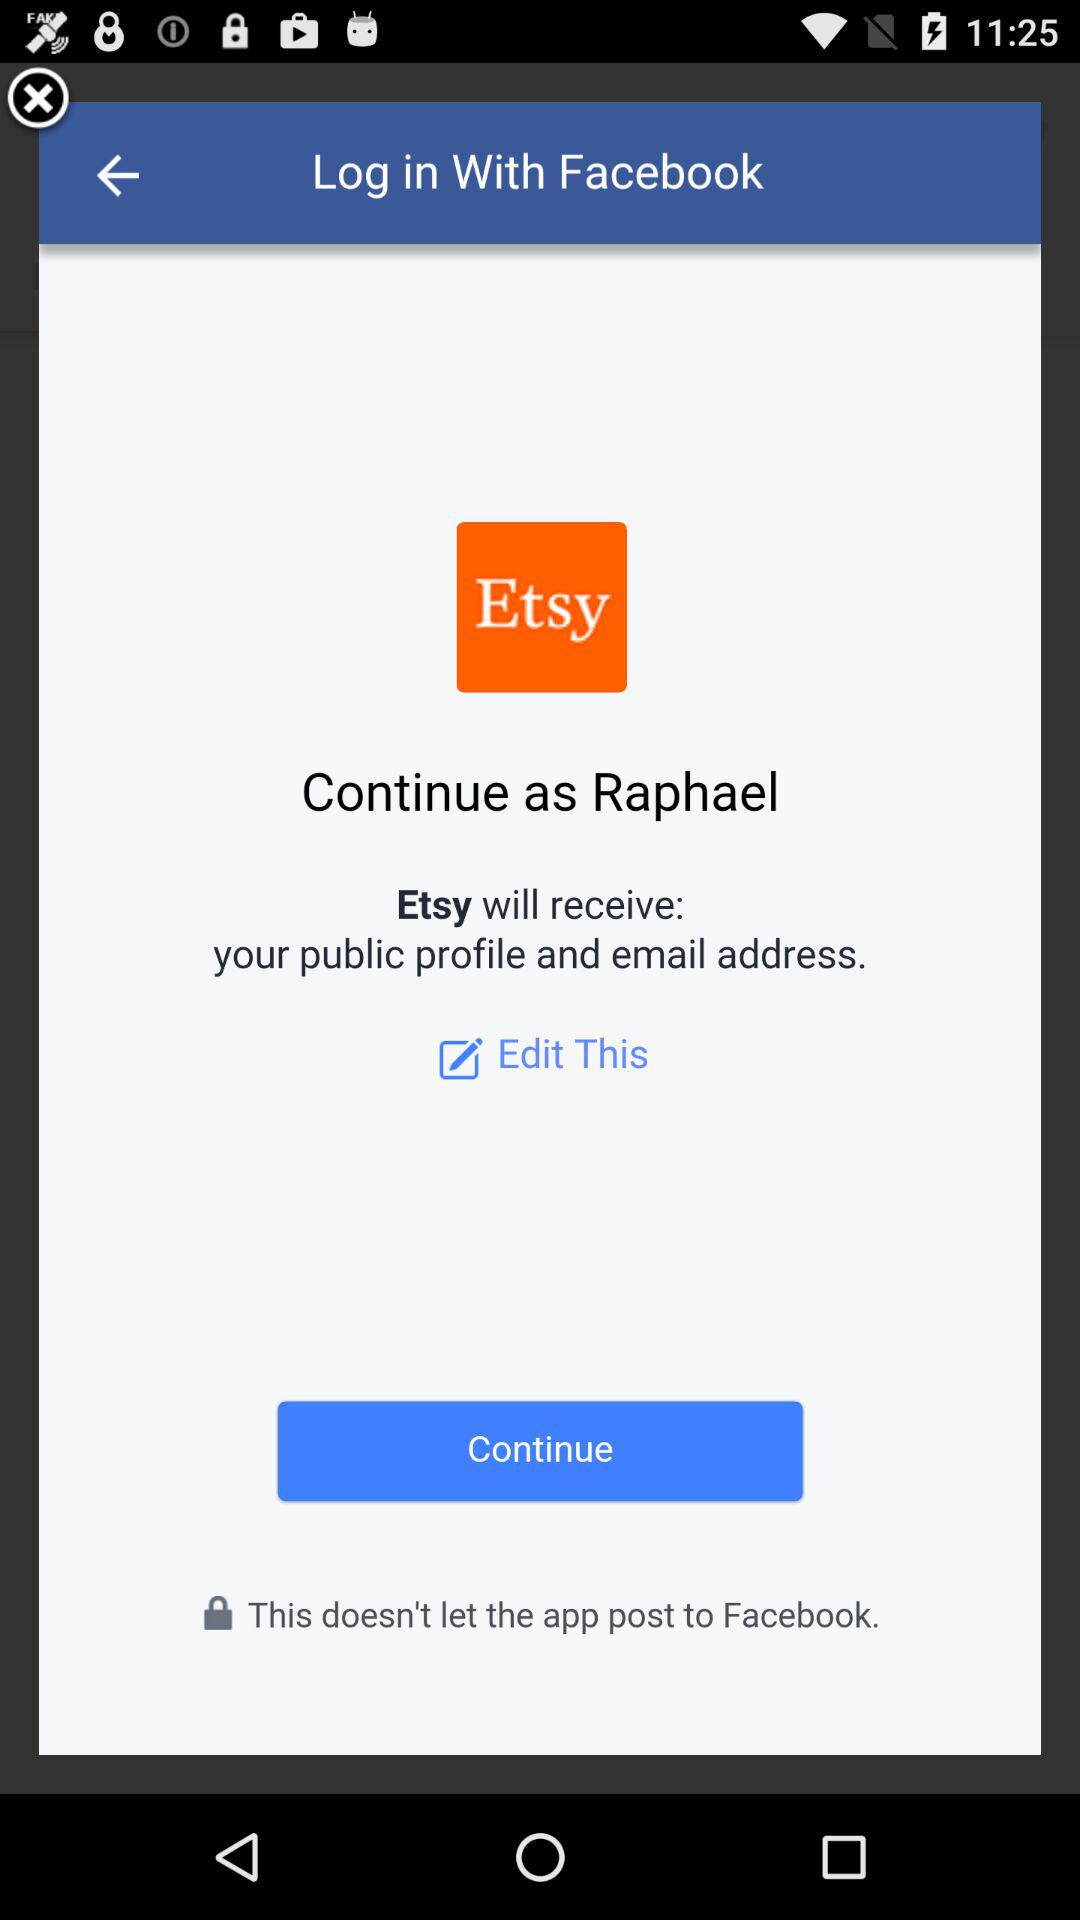What is the name of the user? The name of the user is Raphael. 